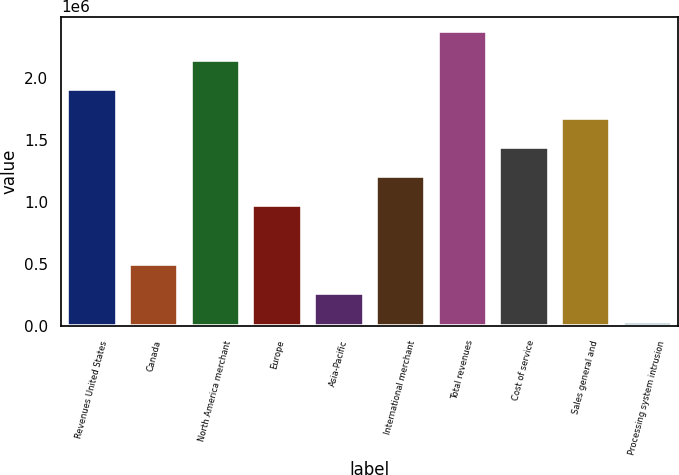Convert chart to OTSL. <chart><loc_0><loc_0><loc_500><loc_500><bar_chart><fcel>Revenues United States<fcel>Canada<fcel>North America merchant<fcel>Europe<fcel>Asia-Pacific<fcel>International merchant<fcel>Total revenues<fcel>Cost of service<fcel>Sales general and<fcel>Processing system intrusion<nl><fcel>1.90809e+06<fcel>504605<fcel>2.14201e+06<fcel>972434<fcel>270690<fcel>1.20635e+06<fcel>2.37592e+06<fcel>1.44026e+06<fcel>1.67418e+06<fcel>36775<nl></chart> 